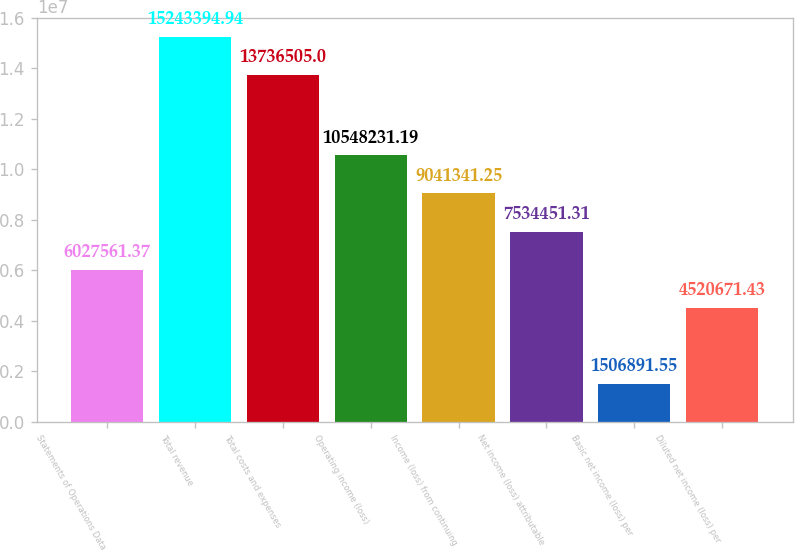Convert chart. <chart><loc_0><loc_0><loc_500><loc_500><bar_chart><fcel>Statements of Operations Data<fcel>Total revenue<fcel>Total costs and expenses<fcel>Operating income (loss)<fcel>Income (loss) from continuing<fcel>Net income (loss) attributable<fcel>Basic net income (loss) per<fcel>Diluted net income (loss) per<nl><fcel>6.02756e+06<fcel>1.52434e+07<fcel>1.37365e+07<fcel>1.05482e+07<fcel>9.04134e+06<fcel>7.53445e+06<fcel>1.50689e+06<fcel>4.52067e+06<nl></chart> 